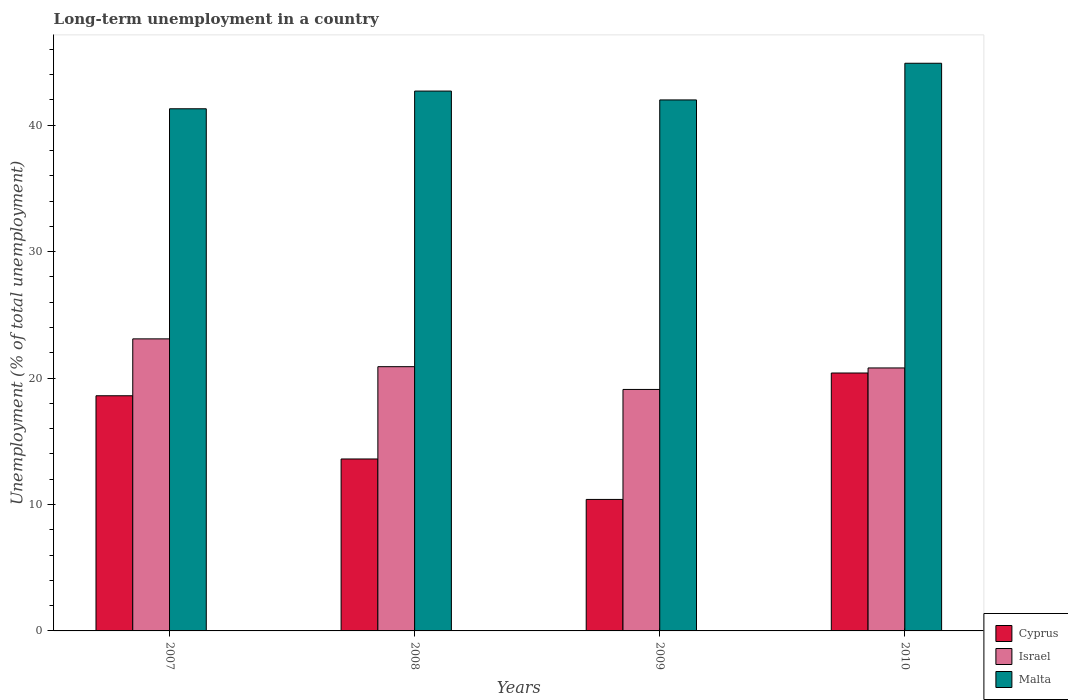How many groups of bars are there?
Keep it short and to the point. 4. Are the number of bars per tick equal to the number of legend labels?
Offer a very short reply. Yes. Are the number of bars on each tick of the X-axis equal?
Make the answer very short. Yes. How many bars are there on the 2nd tick from the right?
Your response must be concise. 3. What is the label of the 1st group of bars from the left?
Offer a terse response. 2007. In how many cases, is the number of bars for a given year not equal to the number of legend labels?
Offer a terse response. 0. What is the percentage of long-term unemployed population in Malta in 2007?
Ensure brevity in your answer.  41.3. Across all years, what is the maximum percentage of long-term unemployed population in Cyprus?
Give a very brief answer. 20.4. Across all years, what is the minimum percentage of long-term unemployed population in Israel?
Your answer should be very brief. 19.1. In which year was the percentage of long-term unemployed population in Malta minimum?
Offer a very short reply. 2007. What is the total percentage of long-term unemployed population in Malta in the graph?
Your answer should be compact. 170.9. What is the difference between the percentage of long-term unemployed population in Cyprus in 2007 and that in 2010?
Keep it short and to the point. -1.8. What is the difference between the percentage of long-term unemployed population in Israel in 2008 and the percentage of long-term unemployed population in Malta in 2010?
Provide a succinct answer. -24. What is the average percentage of long-term unemployed population in Cyprus per year?
Provide a short and direct response. 15.75. In the year 2007, what is the difference between the percentage of long-term unemployed population in Israel and percentage of long-term unemployed population in Cyprus?
Keep it short and to the point. 4.5. In how many years, is the percentage of long-term unemployed population in Israel greater than 2 %?
Offer a very short reply. 4. What is the ratio of the percentage of long-term unemployed population in Malta in 2007 to that in 2008?
Give a very brief answer. 0.97. Is the percentage of long-term unemployed population in Malta in 2008 less than that in 2010?
Make the answer very short. Yes. What is the difference between the highest and the second highest percentage of long-term unemployed population in Malta?
Provide a succinct answer. 2.2. What is the difference between the highest and the lowest percentage of long-term unemployed population in Malta?
Your response must be concise. 3.6. In how many years, is the percentage of long-term unemployed population in Malta greater than the average percentage of long-term unemployed population in Malta taken over all years?
Provide a succinct answer. 1. Is the sum of the percentage of long-term unemployed population in Malta in 2008 and 2010 greater than the maximum percentage of long-term unemployed population in Cyprus across all years?
Provide a short and direct response. Yes. What does the 2nd bar from the left in 2010 represents?
Your response must be concise. Israel. What does the 2nd bar from the right in 2009 represents?
Give a very brief answer. Israel. Are all the bars in the graph horizontal?
Provide a succinct answer. No. How many years are there in the graph?
Give a very brief answer. 4. Does the graph contain any zero values?
Your response must be concise. No. Does the graph contain grids?
Provide a succinct answer. No. Where does the legend appear in the graph?
Provide a short and direct response. Bottom right. What is the title of the graph?
Ensure brevity in your answer.  Long-term unemployment in a country. Does "Trinidad and Tobago" appear as one of the legend labels in the graph?
Give a very brief answer. No. What is the label or title of the X-axis?
Offer a terse response. Years. What is the label or title of the Y-axis?
Your answer should be compact. Unemployment (% of total unemployment). What is the Unemployment (% of total unemployment) of Cyprus in 2007?
Make the answer very short. 18.6. What is the Unemployment (% of total unemployment) of Israel in 2007?
Give a very brief answer. 23.1. What is the Unemployment (% of total unemployment) in Malta in 2007?
Make the answer very short. 41.3. What is the Unemployment (% of total unemployment) in Cyprus in 2008?
Offer a terse response. 13.6. What is the Unemployment (% of total unemployment) in Israel in 2008?
Provide a short and direct response. 20.9. What is the Unemployment (% of total unemployment) of Malta in 2008?
Keep it short and to the point. 42.7. What is the Unemployment (% of total unemployment) of Cyprus in 2009?
Ensure brevity in your answer.  10.4. What is the Unemployment (% of total unemployment) in Israel in 2009?
Provide a short and direct response. 19.1. What is the Unemployment (% of total unemployment) in Malta in 2009?
Keep it short and to the point. 42. What is the Unemployment (% of total unemployment) of Cyprus in 2010?
Ensure brevity in your answer.  20.4. What is the Unemployment (% of total unemployment) of Israel in 2010?
Offer a terse response. 20.8. What is the Unemployment (% of total unemployment) in Malta in 2010?
Your answer should be very brief. 44.9. Across all years, what is the maximum Unemployment (% of total unemployment) of Cyprus?
Offer a very short reply. 20.4. Across all years, what is the maximum Unemployment (% of total unemployment) of Israel?
Give a very brief answer. 23.1. Across all years, what is the maximum Unemployment (% of total unemployment) of Malta?
Offer a very short reply. 44.9. Across all years, what is the minimum Unemployment (% of total unemployment) of Cyprus?
Provide a short and direct response. 10.4. Across all years, what is the minimum Unemployment (% of total unemployment) of Israel?
Give a very brief answer. 19.1. Across all years, what is the minimum Unemployment (% of total unemployment) of Malta?
Give a very brief answer. 41.3. What is the total Unemployment (% of total unemployment) in Cyprus in the graph?
Give a very brief answer. 63. What is the total Unemployment (% of total unemployment) of Israel in the graph?
Ensure brevity in your answer.  83.9. What is the total Unemployment (% of total unemployment) of Malta in the graph?
Your answer should be very brief. 170.9. What is the difference between the Unemployment (% of total unemployment) in Cyprus in 2007 and that in 2008?
Provide a short and direct response. 5. What is the difference between the Unemployment (% of total unemployment) of Malta in 2007 and that in 2008?
Provide a short and direct response. -1.4. What is the difference between the Unemployment (% of total unemployment) in Israel in 2007 and that in 2009?
Your response must be concise. 4. What is the difference between the Unemployment (% of total unemployment) of Cyprus in 2008 and that in 2009?
Your response must be concise. 3.2. What is the difference between the Unemployment (% of total unemployment) in Malta in 2008 and that in 2009?
Make the answer very short. 0.7. What is the difference between the Unemployment (% of total unemployment) in Israel in 2008 and that in 2010?
Provide a succinct answer. 0.1. What is the difference between the Unemployment (% of total unemployment) of Cyprus in 2009 and that in 2010?
Offer a terse response. -10. What is the difference between the Unemployment (% of total unemployment) of Cyprus in 2007 and the Unemployment (% of total unemployment) of Israel in 2008?
Your response must be concise. -2.3. What is the difference between the Unemployment (% of total unemployment) of Cyprus in 2007 and the Unemployment (% of total unemployment) of Malta in 2008?
Provide a succinct answer. -24.1. What is the difference between the Unemployment (% of total unemployment) in Israel in 2007 and the Unemployment (% of total unemployment) in Malta in 2008?
Your response must be concise. -19.6. What is the difference between the Unemployment (% of total unemployment) in Cyprus in 2007 and the Unemployment (% of total unemployment) in Malta in 2009?
Offer a very short reply. -23.4. What is the difference between the Unemployment (% of total unemployment) of Israel in 2007 and the Unemployment (% of total unemployment) of Malta in 2009?
Provide a succinct answer. -18.9. What is the difference between the Unemployment (% of total unemployment) of Cyprus in 2007 and the Unemployment (% of total unemployment) of Israel in 2010?
Offer a terse response. -2.2. What is the difference between the Unemployment (% of total unemployment) in Cyprus in 2007 and the Unemployment (% of total unemployment) in Malta in 2010?
Ensure brevity in your answer.  -26.3. What is the difference between the Unemployment (% of total unemployment) of Israel in 2007 and the Unemployment (% of total unemployment) of Malta in 2010?
Your answer should be compact. -21.8. What is the difference between the Unemployment (% of total unemployment) in Cyprus in 2008 and the Unemployment (% of total unemployment) in Israel in 2009?
Offer a terse response. -5.5. What is the difference between the Unemployment (% of total unemployment) of Cyprus in 2008 and the Unemployment (% of total unemployment) of Malta in 2009?
Provide a succinct answer. -28.4. What is the difference between the Unemployment (% of total unemployment) of Israel in 2008 and the Unemployment (% of total unemployment) of Malta in 2009?
Your response must be concise. -21.1. What is the difference between the Unemployment (% of total unemployment) in Cyprus in 2008 and the Unemployment (% of total unemployment) in Israel in 2010?
Your response must be concise. -7.2. What is the difference between the Unemployment (% of total unemployment) in Cyprus in 2008 and the Unemployment (% of total unemployment) in Malta in 2010?
Provide a short and direct response. -31.3. What is the difference between the Unemployment (% of total unemployment) in Israel in 2008 and the Unemployment (% of total unemployment) in Malta in 2010?
Provide a short and direct response. -24. What is the difference between the Unemployment (% of total unemployment) in Cyprus in 2009 and the Unemployment (% of total unemployment) in Malta in 2010?
Your response must be concise. -34.5. What is the difference between the Unemployment (% of total unemployment) in Israel in 2009 and the Unemployment (% of total unemployment) in Malta in 2010?
Offer a terse response. -25.8. What is the average Unemployment (% of total unemployment) in Cyprus per year?
Provide a succinct answer. 15.75. What is the average Unemployment (% of total unemployment) in Israel per year?
Offer a terse response. 20.98. What is the average Unemployment (% of total unemployment) in Malta per year?
Offer a very short reply. 42.73. In the year 2007, what is the difference between the Unemployment (% of total unemployment) of Cyprus and Unemployment (% of total unemployment) of Malta?
Provide a succinct answer. -22.7. In the year 2007, what is the difference between the Unemployment (% of total unemployment) of Israel and Unemployment (% of total unemployment) of Malta?
Make the answer very short. -18.2. In the year 2008, what is the difference between the Unemployment (% of total unemployment) of Cyprus and Unemployment (% of total unemployment) of Israel?
Provide a succinct answer. -7.3. In the year 2008, what is the difference between the Unemployment (% of total unemployment) of Cyprus and Unemployment (% of total unemployment) of Malta?
Make the answer very short. -29.1. In the year 2008, what is the difference between the Unemployment (% of total unemployment) in Israel and Unemployment (% of total unemployment) in Malta?
Provide a succinct answer. -21.8. In the year 2009, what is the difference between the Unemployment (% of total unemployment) in Cyprus and Unemployment (% of total unemployment) in Malta?
Your answer should be compact. -31.6. In the year 2009, what is the difference between the Unemployment (% of total unemployment) of Israel and Unemployment (% of total unemployment) of Malta?
Offer a terse response. -22.9. In the year 2010, what is the difference between the Unemployment (% of total unemployment) of Cyprus and Unemployment (% of total unemployment) of Israel?
Offer a terse response. -0.4. In the year 2010, what is the difference between the Unemployment (% of total unemployment) in Cyprus and Unemployment (% of total unemployment) in Malta?
Give a very brief answer. -24.5. In the year 2010, what is the difference between the Unemployment (% of total unemployment) of Israel and Unemployment (% of total unemployment) of Malta?
Keep it short and to the point. -24.1. What is the ratio of the Unemployment (% of total unemployment) of Cyprus in 2007 to that in 2008?
Offer a terse response. 1.37. What is the ratio of the Unemployment (% of total unemployment) in Israel in 2007 to that in 2008?
Ensure brevity in your answer.  1.11. What is the ratio of the Unemployment (% of total unemployment) of Malta in 2007 to that in 2008?
Offer a terse response. 0.97. What is the ratio of the Unemployment (% of total unemployment) of Cyprus in 2007 to that in 2009?
Offer a very short reply. 1.79. What is the ratio of the Unemployment (% of total unemployment) in Israel in 2007 to that in 2009?
Your answer should be very brief. 1.21. What is the ratio of the Unemployment (% of total unemployment) in Malta in 2007 to that in 2009?
Provide a short and direct response. 0.98. What is the ratio of the Unemployment (% of total unemployment) in Cyprus in 2007 to that in 2010?
Your answer should be compact. 0.91. What is the ratio of the Unemployment (% of total unemployment) in Israel in 2007 to that in 2010?
Offer a very short reply. 1.11. What is the ratio of the Unemployment (% of total unemployment) in Malta in 2007 to that in 2010?
Give a very brief answer. 0.92. What is the ratio of the Unemployment (% of total unemployment) in Cyprus in 2008 to that in 2009?
Your answer should be very brief. 1.31. What is the ratio of the Unemployment (% of total unemployment) in Israel in 2008 to that in 2009?
Give a very brief answer. 1.09. What is the ratio of the Unemployment (% of total unemployment) in Malta in 2008 to that in 2009?
Provide a succinct answer. 1.02. What is the ratio of the Unemployment (% of total unemployment) in Israel in 2008 to that in 2010?
Your answer should be very brief. 1. What is the ratio of the Unemployment (% of total unemployment) in Malta in 2008 to that in 2010?
Your response must be concise. 0.95. What is the ratio of the Unemployment (% of total unemployment) in Cyprus in 2009 to that in 2010?
Ensure brevity in your answer.  0.51. What is the ratio of the Unemployment (% of total unemployment) in Israel in 2009 to that in 2010?
Your answer should be compact. 0.92. What is the ratio of the Unemployment (% of total unemployment) of Malta in 2009 to that in 2010?
Offer a terse response. 0.94. What is the difference between the highest and the second highest Unemployment (% of total unemployment) of Israel?
Your answer should be very brief. 2.2. What is the difference between the highest and the lowest Unemployment (% of total unemployment) of Cyprus?
Give a very brief answer. 10. What is the difference between the highest and the lowest Unemployment (% of total unemployment) of Malta?
Your answer should be very brief. 3.6. 